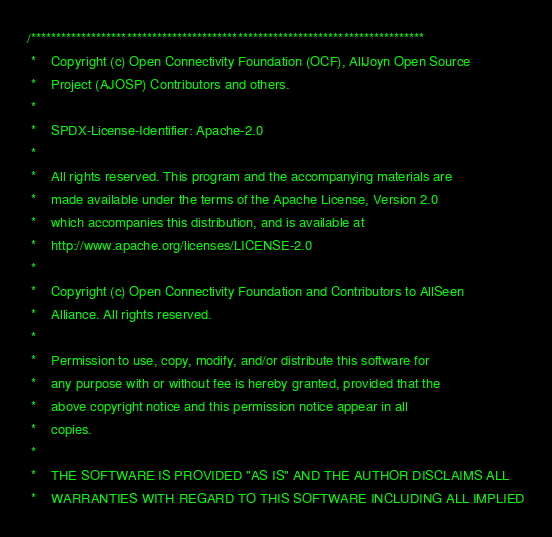Convert code to text. <code><loc_0><loc_0><loc_500><loc_500><_ObjectiveC_>/******************************************************************************
 *    Copyright (c) Open Connectivity Foundation (OCF), AllJoyn Open Source
 *    Project (AJOSP) Contributors and others.
 *    
 *    SPDX-License-Identifier: Apache-2.0
 *    
 *    All rights reserved. This program and the accompanying materials are
 *    made available under the terms of the Apache License, Version 2.0
 *    which accompanies this distribution, and is available at
 *    http://www.apache.org/licenses/LICENSE-2.0
 *    
 *    Copyright (c) Open Connectivity Foundation and Contributors to AllSeen
 *    Alliance. All rights reserved.
 *    
 *    Permission to use, copy, modify, and/or distribute this software for
 *    any purpose with or without fee is hereby granted, provided that the
 *    above copyright notice and this permission notice appear in all
 *    copies.
 *    
 *    THE SOFTWARE IS PROVIDED "AS IS" AND THE AUTHOR DISCLAIMS ALL
 *    WARRANTIES WITH REGARD TO THIS SOFTWARE INCLUDING ALL IMPLIED</code> 